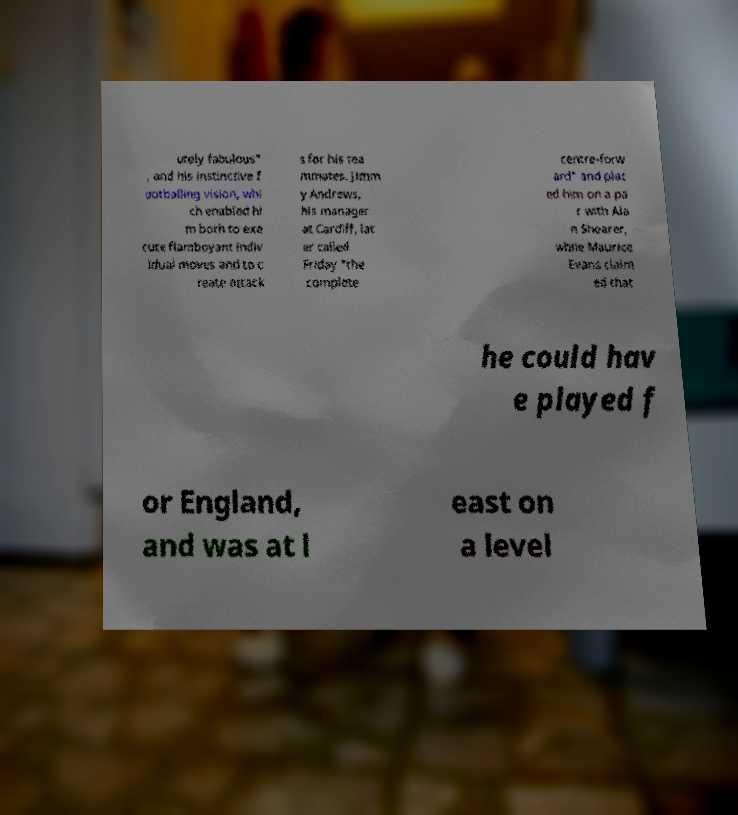Can you read and provide the text displayed in the image?This photo seems to have some interesting text. Can you extract and type it out for me? utely fabulous" , and his instinctive f ootballing vision, whi ch enabled hi m both to exe cute flamboyant indiv idual moves and to c reate attack s for his tea mmates. Jimm y Andrews, his manager at Cardiff, lat er called Friday "the complete centre-forw ard" and plac ed him on a pa r with Ala n Shearer, while Maurice Evans claim ed that he could hav e played f or England, and was at l east on a level 